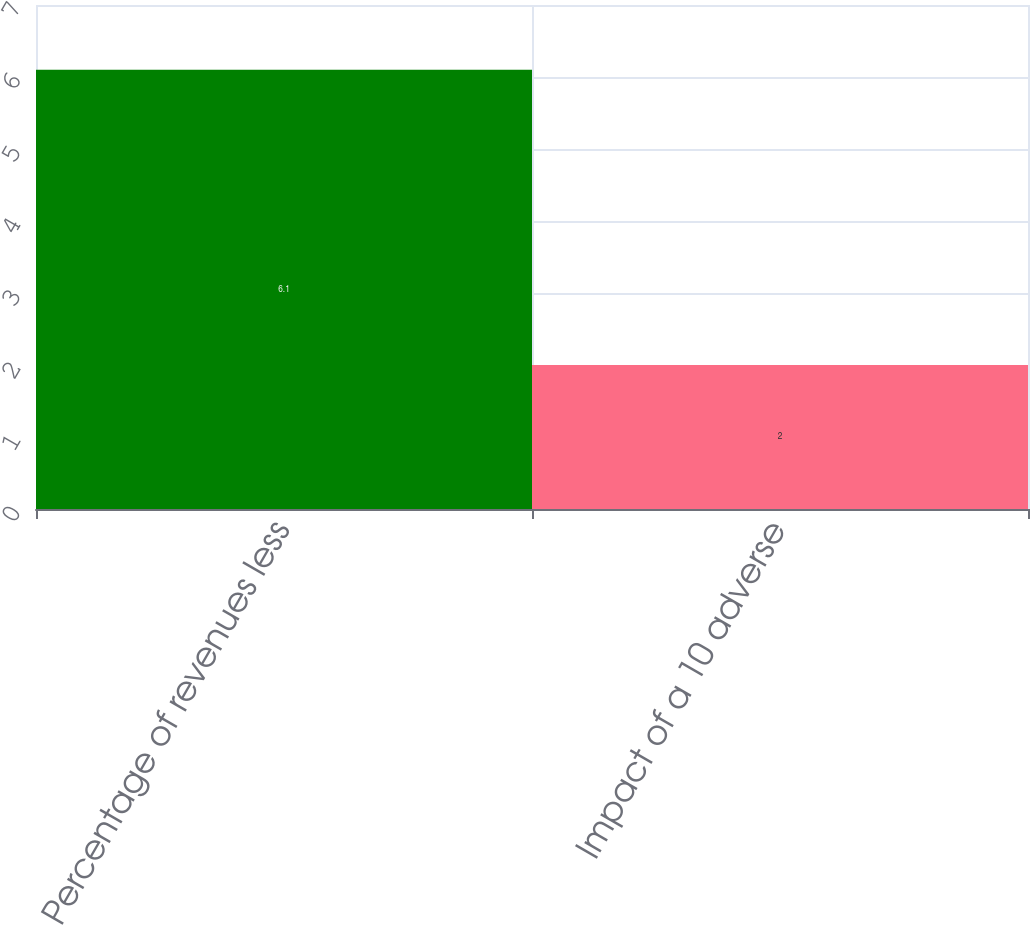Convert chart to OTSL. <chart><loc_0><loc_0><loc_500><loc_500><bar_chart><fcel>Percentage of revenues less<fcel>Impact of a 10 adverse<nl><fcel>6.1<fcel>2<nl></chart> 